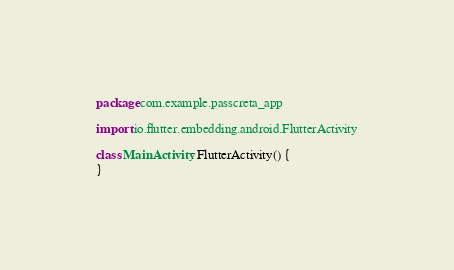<code> <loc_0><loc_0><loc_500><loc_500><_Kotlin_>package com.example.passcreta_app

import io.flutter.embedding.android.FlutterActivity

class MainActivity: FlutterActivity() {
}
</code> 